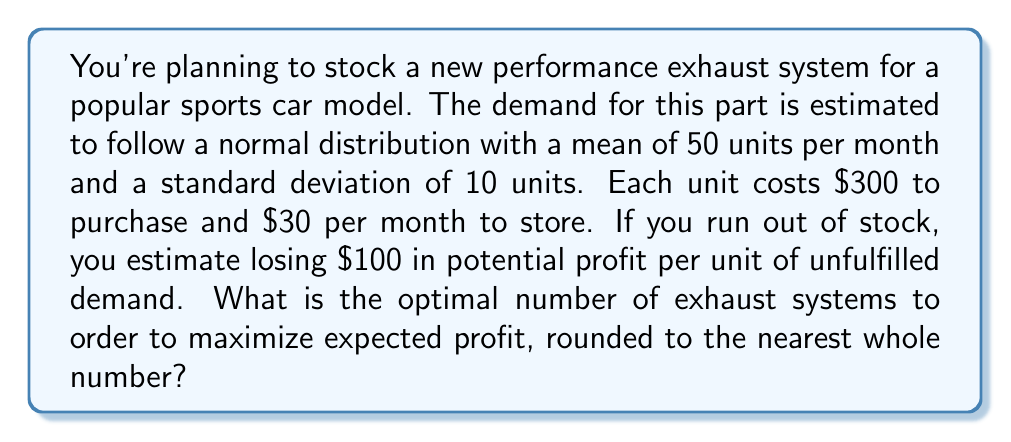Could you help me with this problem? To solve this problem, we'll use the newsvendor model from inventory management theory. The optimal order quantity is determined by the critical fractile formula:

$$F(Q^*) = \frac{c_u}{c_u + c_o}$$

Where:
$F(Q^*)$ is the cumulative distribution function of demand at the optimal quantity
$c_u$ is the underage cost (cost of not having enough stock)
$c_o$ is the overage cost (cost of having too much stock)

1. Calculate the underage cost ($c_u$):
   $c_u = \text{Lost profit} = $100$

2. Calculate the overage cost ($c_o$):
   $c_o = \text{Purchase cost} + \text{Storage cost} - \text{Salvage value}$
   Assuming no salvage value: $c_o = $300 + $30 = $330$

3. Calculate the critical fractile:
   $$\frac{c_u}{c_u + c_o} = \frac{100}{100 + 330} \approx 0.2326$$

4. Find the z-score corresponding to this fractile using the inverse normal distribution:
   $z \approx -0.73$

5. Calculate the optimal quantity:
   $$Q^* = \mu + z\sigma = 50 + (-0.73 \times 10) = 42.7$$

6. Round to the nearest whole number:
   $Q^* \approx 43$

Therefore, the optimal number of exhaust systems to order is 43 units.
Answer: 43 units 